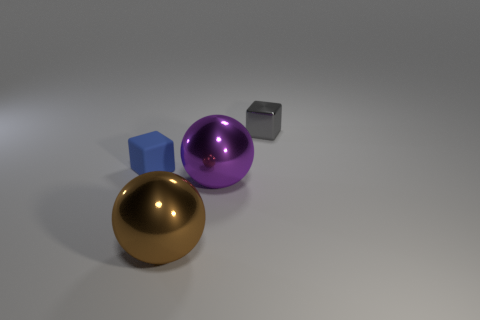Add 3 purple blocks. How many objects exist? 7 Subtract 0 red cubes. How many objects are left? 4 Subtract all large shiny spheres. Subtract all big purple balls. How many objects are left? 1 Add 2 big metal spheres. How many big metal spheres are left? 4 Add 2 big brown shiny spheres. How many big brown shiny spheres exist? 3 